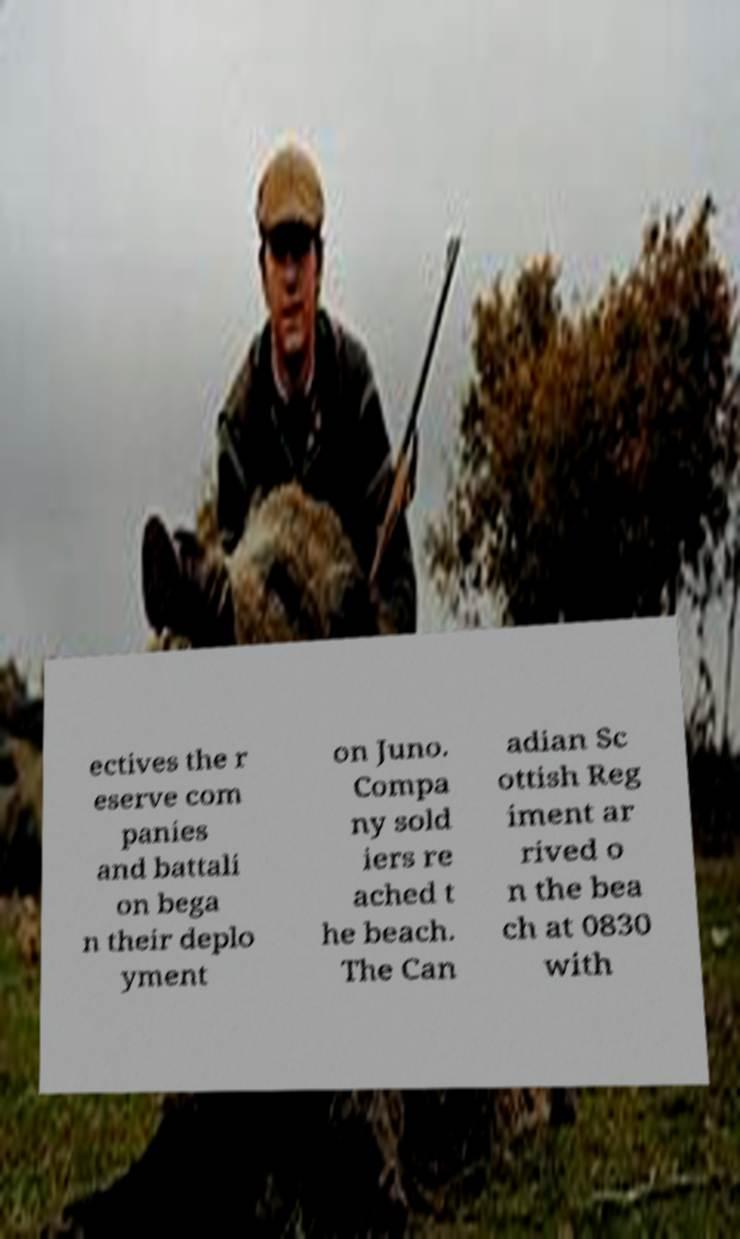Can you accurately transcribe the text from the provided image for me? ectives the r eserve com panies and battali on bega n their deplo yment on Juno. Compa ny sold iers re ached t he beach. The Can adian Sc ottish Reg iment ar rived o n the bea ch at 0830 with 